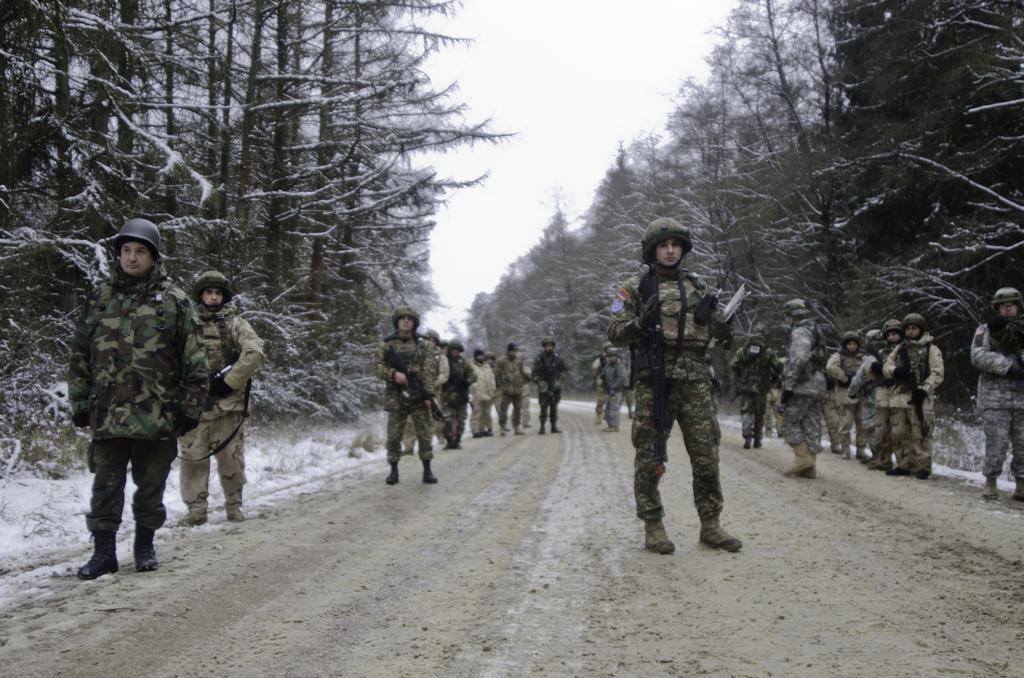In one or two sentences, can you explain what this image depicts? This picture is clicked outside. In the center we can see the group of people wearing uniforms and seems to be standing on the ground. In the background we can see the sky, trees and the snow. 